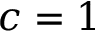<formula> <loc_0><loc_0><loc_500><loc_500>c = 1</formula> 